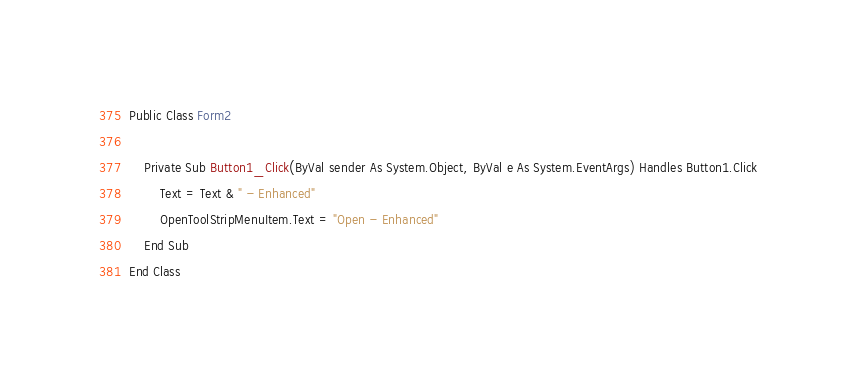<code> <loc_0><loc_0><loc_500><loc_500><_VisualBasic_>Public Class Form2

    Private Sub Button1_Click(ByVal sender As System.Object, ByVal e As System.EventArgs) Handles Button1.Click
        Text = Text & " - Enhanced"
        OpenToolStripMenuItem.Text = "Open - Enhanced"
    End Sub
End Class</code> 